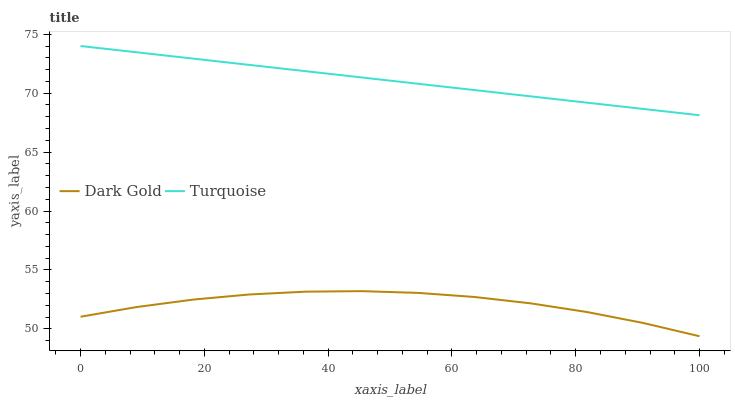Does Dark Gold have the minimum area under the curve?
Answer yes or no. Yes. Does Turquoise have the maximum area under the curve?
Answer yes or no. Yes. Does Dark Gold have the maximum area under the curve?
Answer yes or no. No. Is Turquoise the smoothest?
Answer yes or no. Yes. Is Dark Gold the roughest?
Answer yes or no. Yes. Is Dark Gold the smoothest?
Answer yes or no. No. Does Dark Gold have the lowest value?
Answer yes or no. Yes. Does Turquoise have the highest value?
Answer yes or no. Yes. Does Dark Gold have the highest value?
Answer yes or no. No. Is Dark Gold less than Turquoise?
Answer yes or no. Yes. Is Turquoise greater than Dark Gold?
Answer yes or no. Yes. Does Dark Gold intersect Turquoise?
Answer yes or no. No. 